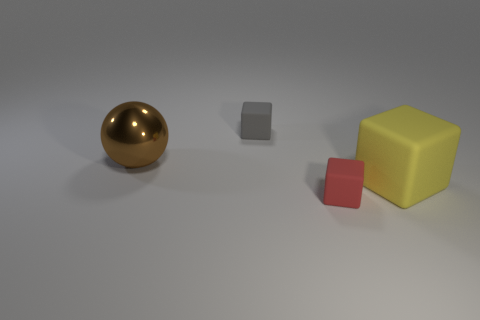Add 2 red objects. How many objects exist? 6 Subtract all spheres. How many objects are left? 3 Subtract 0 blue cubes. How many objects are left? 4 Subtract all purple shiny things. Subtract all large objects. How many objects are left? 2 Add 2 big objects. How many big objects are left? 4 Add 4 small red shiny things. How many small red shiny things exist? 4 